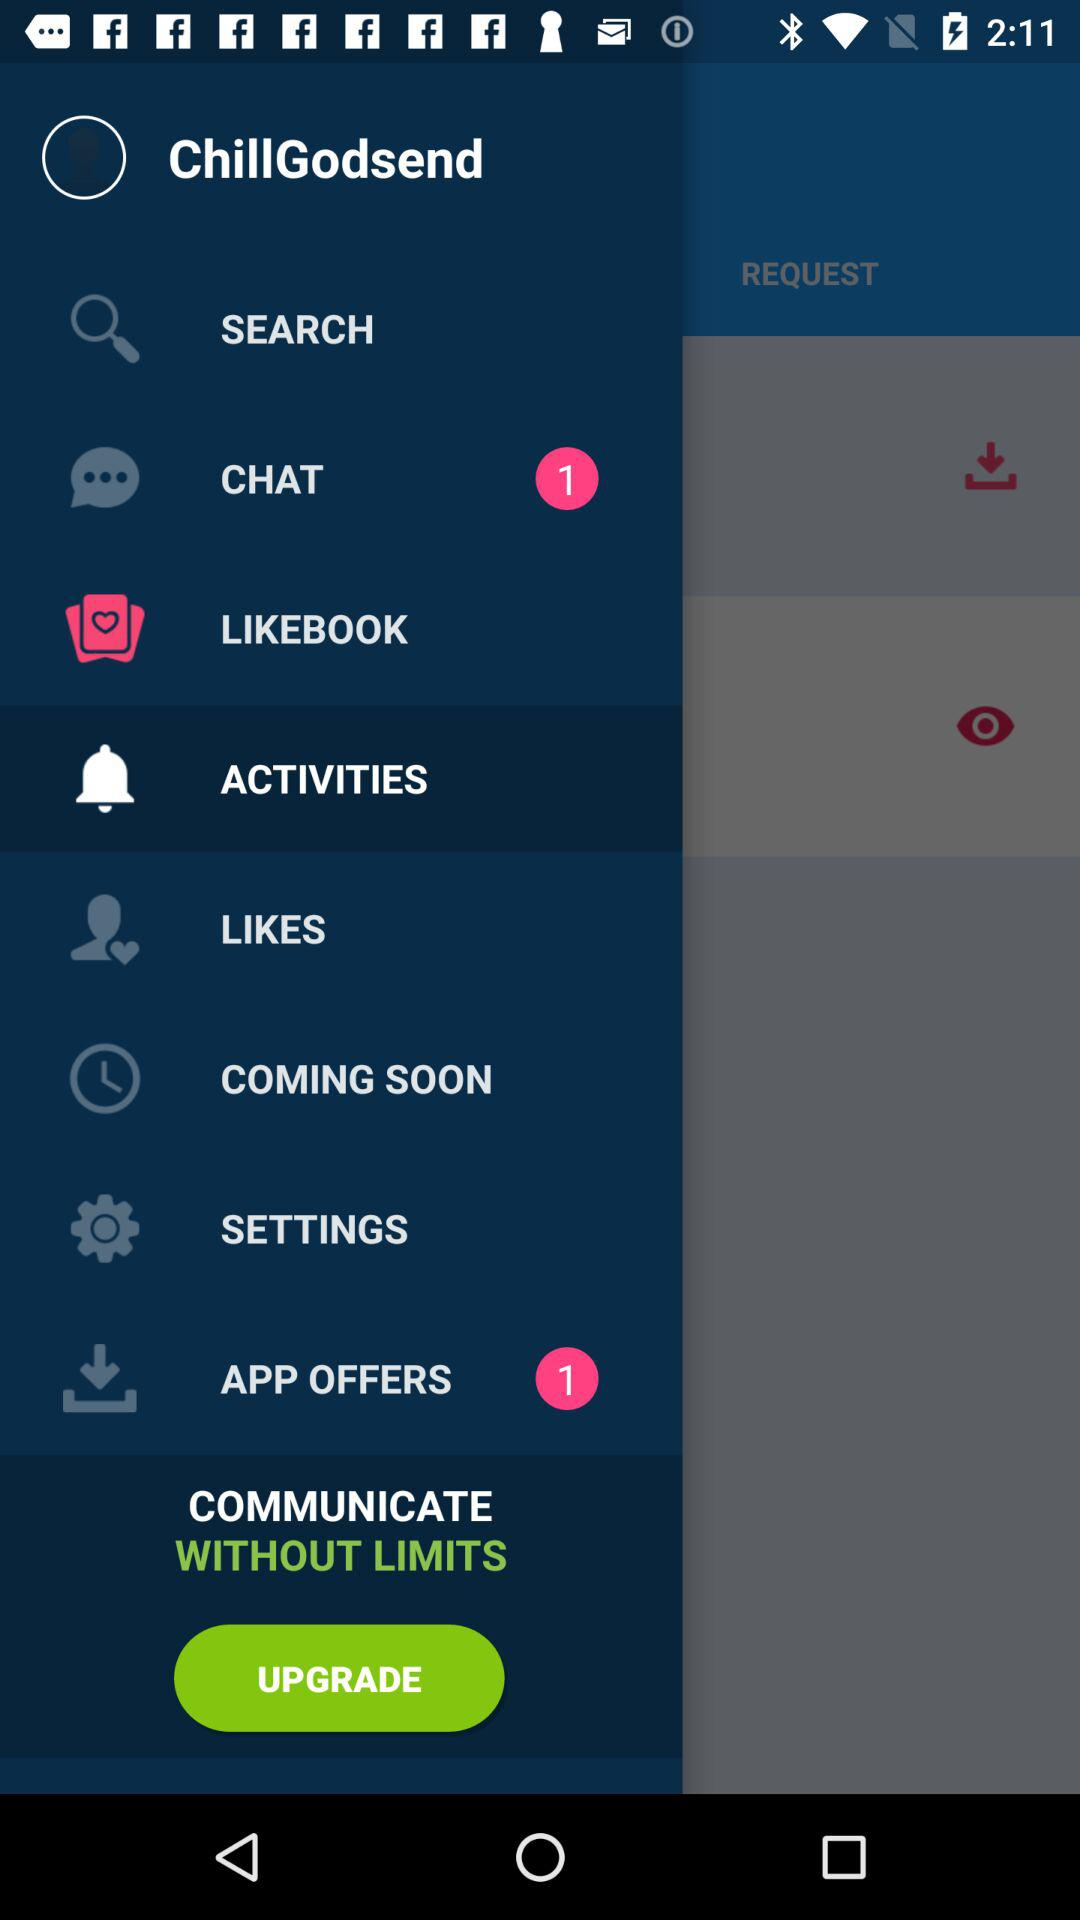How many notifications are pending in "CHAT"? There is 1 notification pending in "CHAT". 